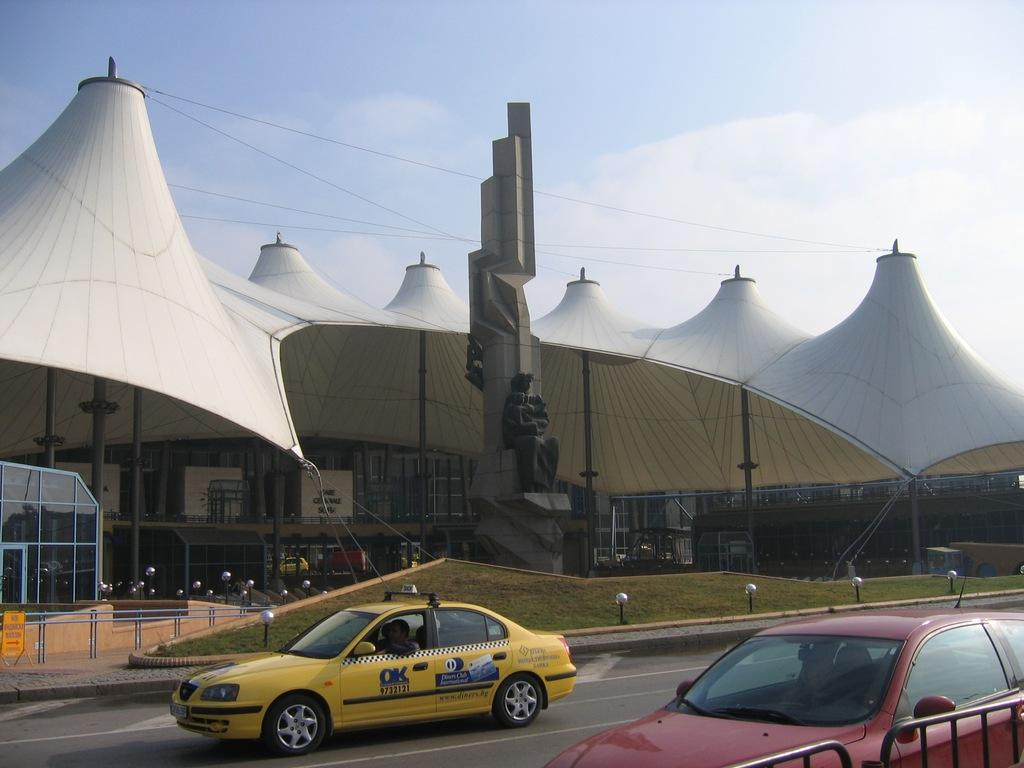<image>
Share a concise interpretation of the image provided. A red car is driving past an ornate building and a yellow car that says OK on the side is next to it. 